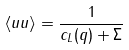<formula> <loc_0><loc_0><loc_500><loc_500>\langle u u \rangle = \frac { 1 } { c _ { L } ( q ) + \Sigma }</formula> 